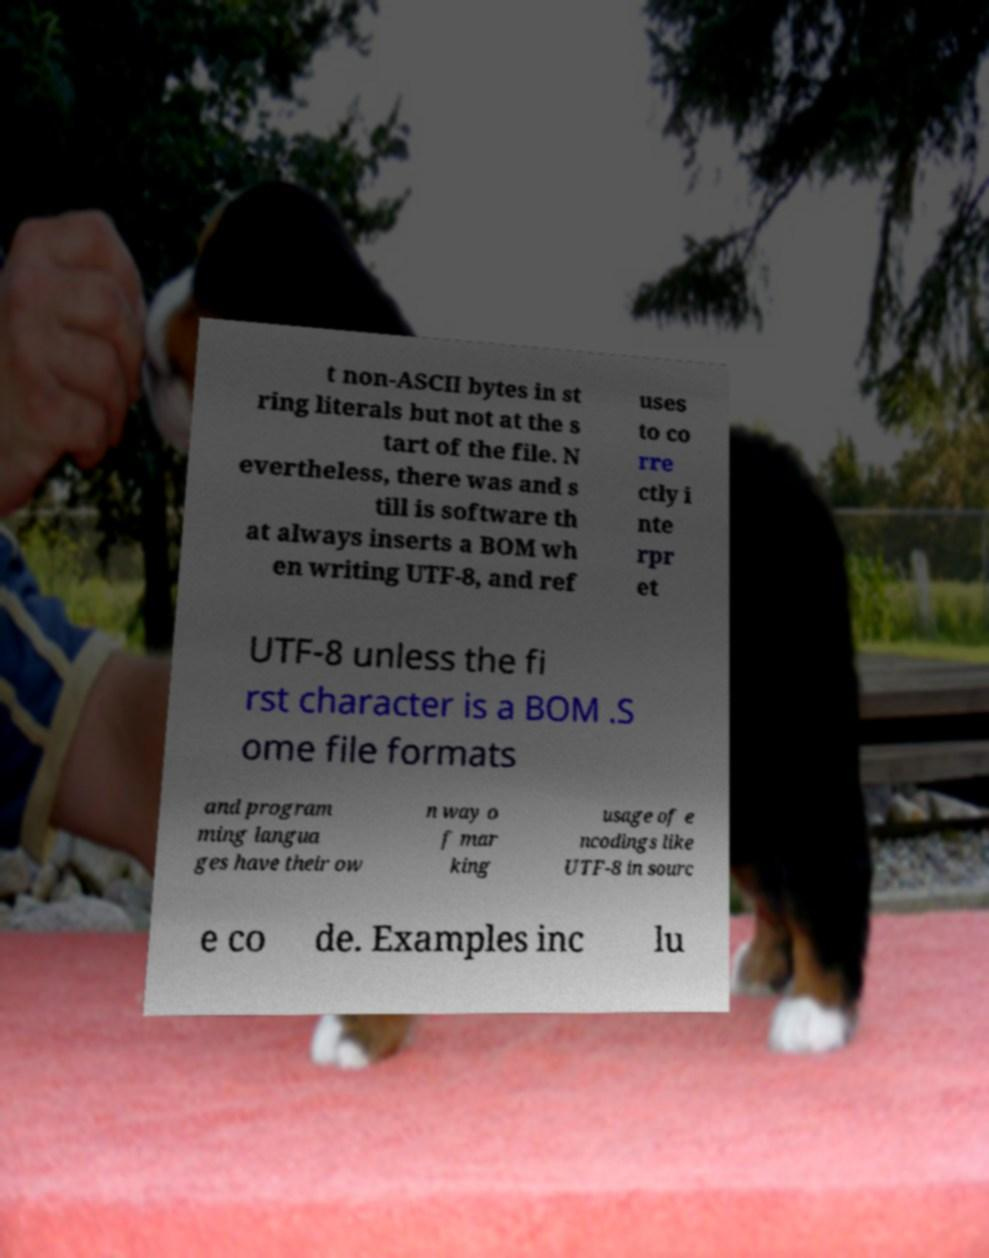Can you accurately transcribe the text from the provided image for me? t non-ASCII bytes in st ring literals but not at the s tart of the file. N evertheless, there was and s till is software th at always inserts a BOM wh en writing UTF-8, and ref uses to co rre ctly i nte rpr et UTF-8 unless the fi rst character is a BOM .S ome file formats and program ming langua ges have their ow n way o f mar king usage of e ncodings like UTF-8 in sourc e co de. Examples inc lu 